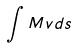<formula> <loc_0><loc_0><loc_500><loc_500>\int M v d s</formula> 